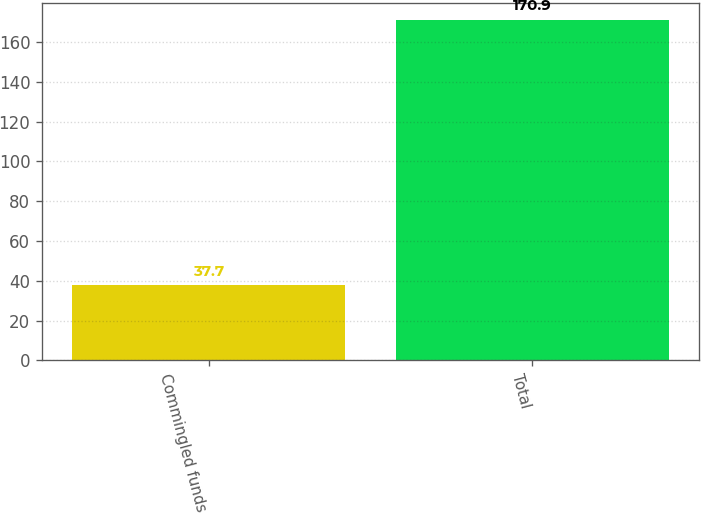Convert chart. <chart><loc_0><loc_0><loc_500><loc_500><bar_chart><fcel>Commingled funds<fcel>Total<nl><fcel>37.7<fcel>170.9<nl></chart> 